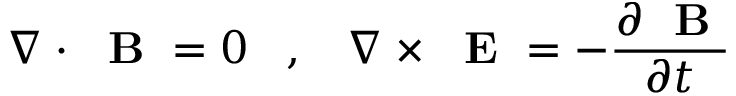Convert formula to latex. <formula><loc_0><loc_0><loc_500><loc_500>\nabla \cdot B = 0 \, , \, \nabla \times E = - \frac { \partial B } { \partial t }</formula> 